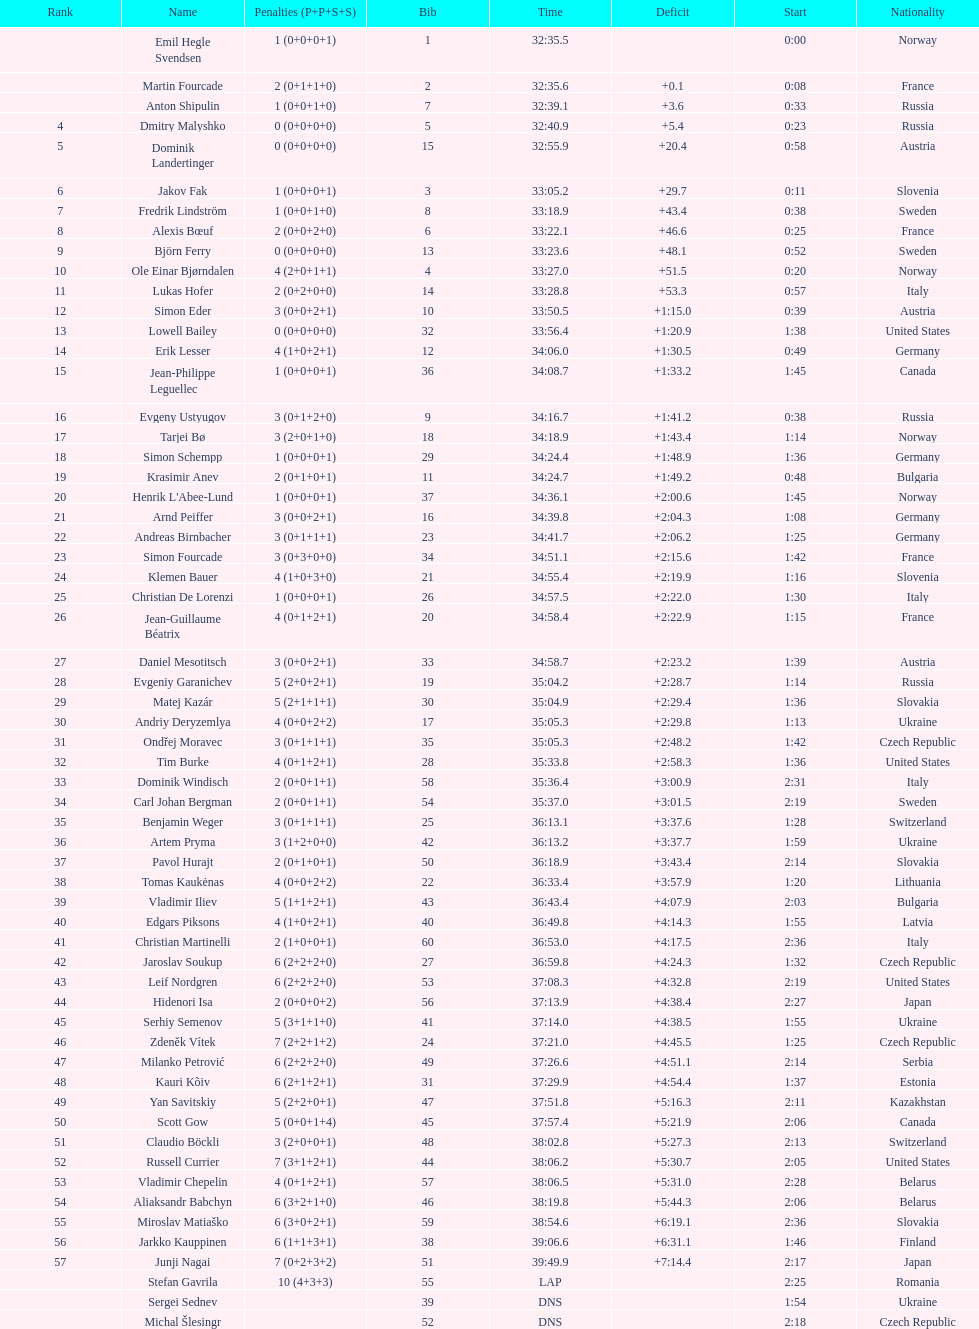What was the total number of penalties germany got? 11. 